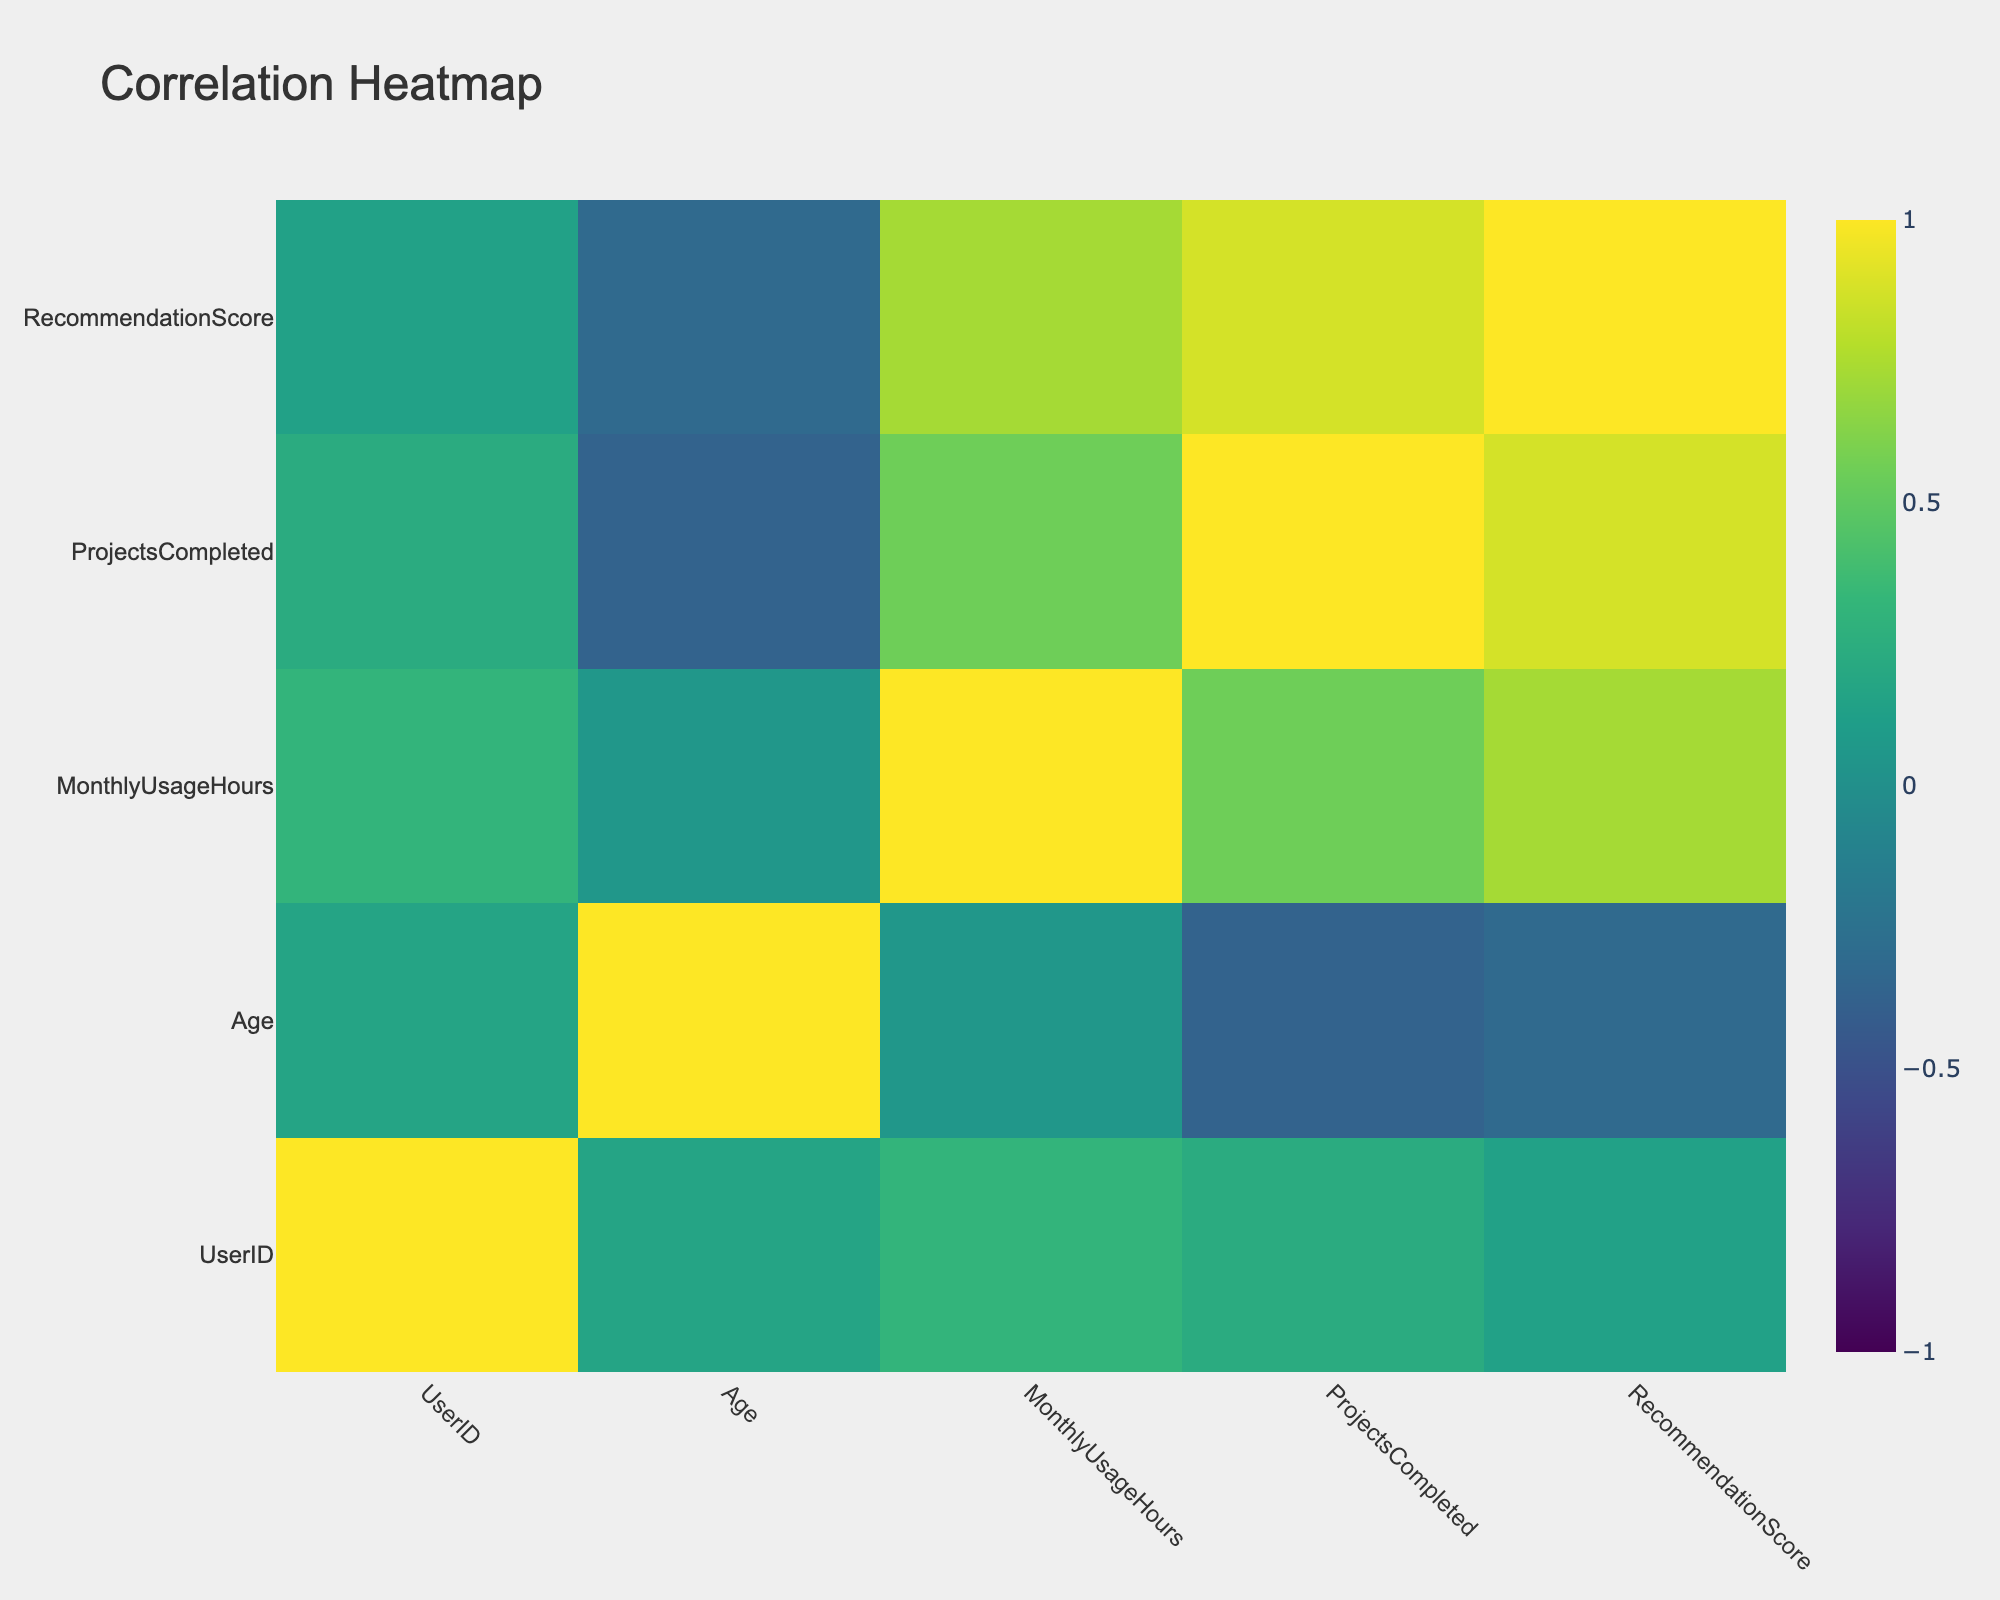What is the maximum recommendation score? The recommendation scores listed in the table are 8, 9, 7, 6, 9, 10, 8, 7, 8, and 9. The highest value among these is 10.
Answer: 10 What is the average monthly usage hours for users with a professional subscription? The users with a professional subscription and their monthly usage hours are 40, 35, and 20. The total sum is 40 + 35 + 20 = 95, and there are 3 users, so the average is 95 / 3 = 31.67.
Answer: 31.67 Is there a female user who completed more than 18 projects? Looking at the users marked as female, the completed projects are 12, 10, 20, 15, and 22. Since 20 and 22 are greater than 18, the answer is yes.
Answer: Yes What is the difference in completed projects between the highest and lowest among all users? The completed projects are 12, 18, 10, 5, 20, 25, 15, 8, 22, and 15. The highest is 25 and the lowest is 5. The difference is 25 - 5 = 20.
Answer: 20 How many users prefer Canva? In the table, two users prefer Canva (User 1 and User 7). Therefore, count them to find there are 2 users.
Answer: 2 What is the total number of projects completed by all male users? The completed projects for male users are 18, 5, 25, 8, and 15. The total is 18 + 5 + 25 + 8 + 15 = 71.
Answer: 71 What age group is represented by users who prefer Adobe Spark? The user preferring Adobe Spark is User 2, who is 33 years old, making the age group exclusively 33 years, as no other data points are relevant to Adobe Spark.
Answer: 33 Which subscription type is associated with the user who completed the most projects? User 6 completed 25 projects and has a professional subscription. Since this is the highest completed projects count, we conclude that the associated subscription type is professional.
Answer: Professional What is the average design complexity for users who have a premium subscription? The users with a premium subscription have medium complexity (Users 2, 5, and 8). Since all these have the same design complexity type, the average remains medium.
Answer: Medium 